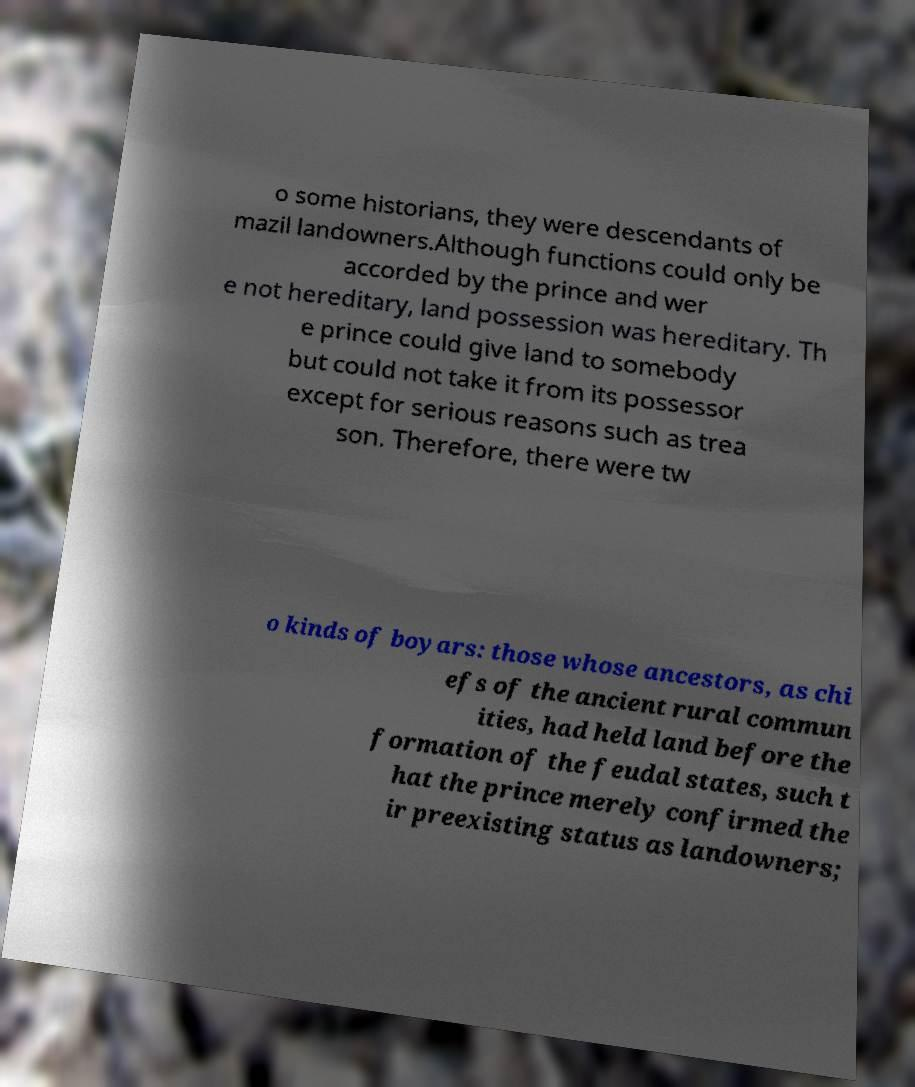Can you read and provide the text displayed in the image?This photo seems to have some interesting text. Can you extract and type it out for me? o some historians, they were descendants of mazil landowners.Although functions could only be accorded by the prince and wer e not hereditary, land possession was hereditary. Th e prince could give land to somebody but could not take it from its possessor except for serious reasons such as trea son. Therefore, there were tw o kinds of boyars: those whose ancestors, as chi efs of the ancient rural commun ities, had held land before the formation of the feudal states, such t hat the prince merely confirmed the ir preexisting status as landowners; 